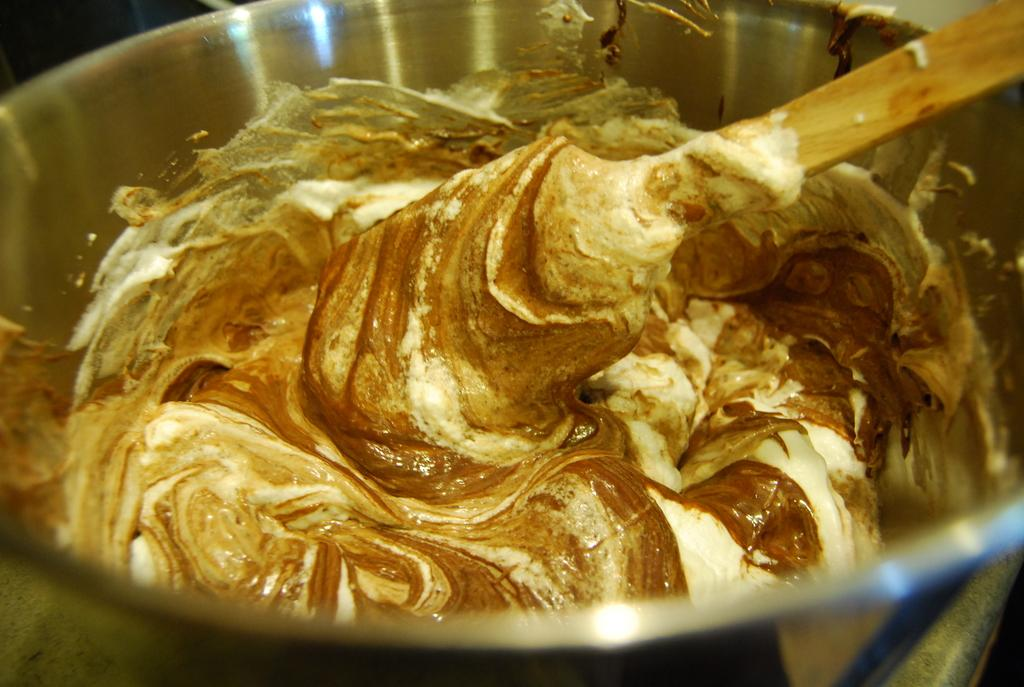What is in the bowl that is visible in the image? The bowl contains butter in the image. What utensil is present in the image? There is a ladle in the image. What type of country is depicted in the image? There is no country depicted in the image; it features a bowl of butter and a ladle. What type of jeans is the person wearing in the image? There is no person present in the image, so it is not possible to determine what type of jeans they might be wearing. 